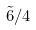<formula> <loc_0><loc_0><loc_500><loc_500>\tilde { 6 } / 4</formula> 